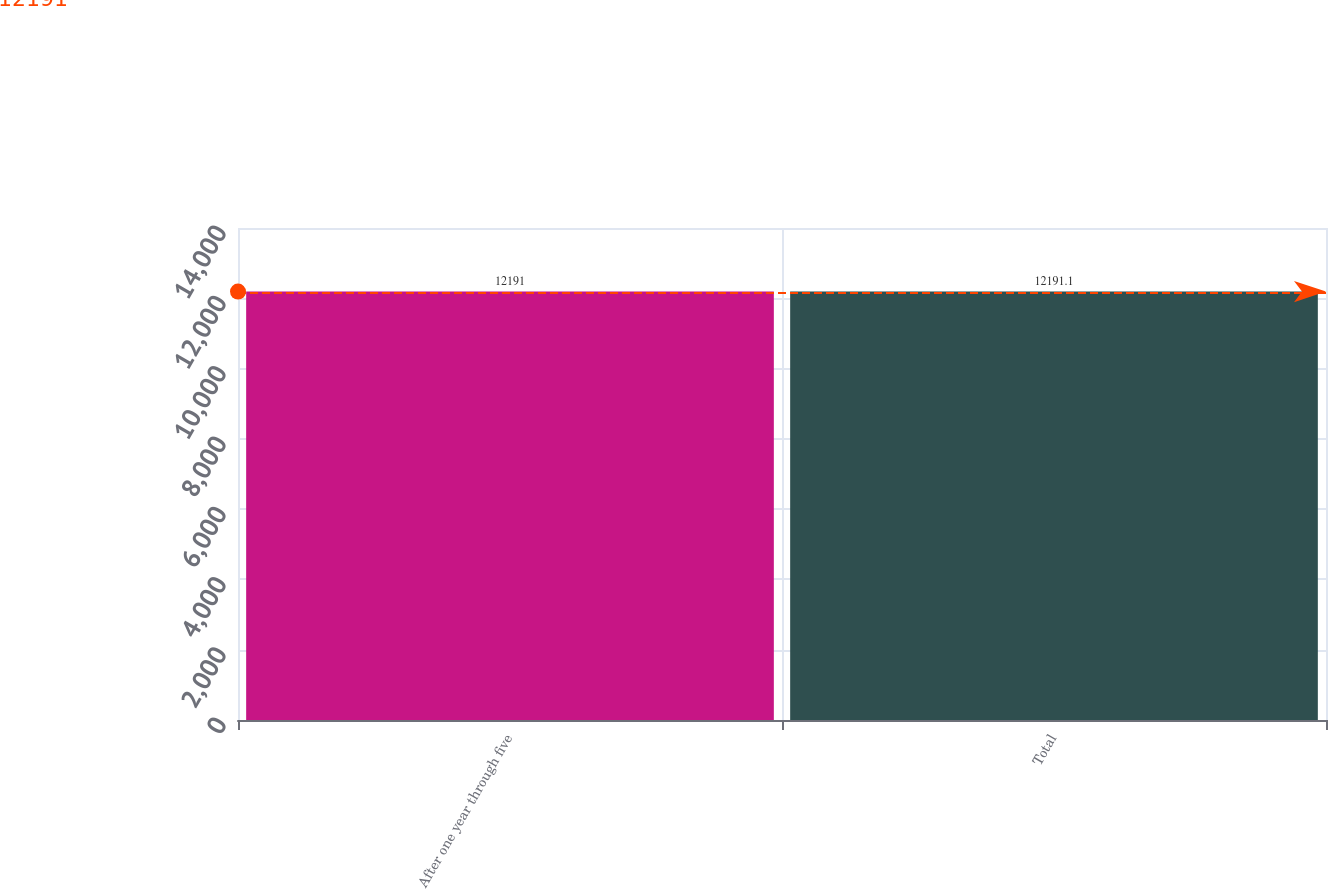<chart> <loc_0><loc_0><loc_500><loc_500><bar_chart><fcel>After one year through five<fcel>Total<nl><fcel>12191<fcel>12191.1<nl></chart> 